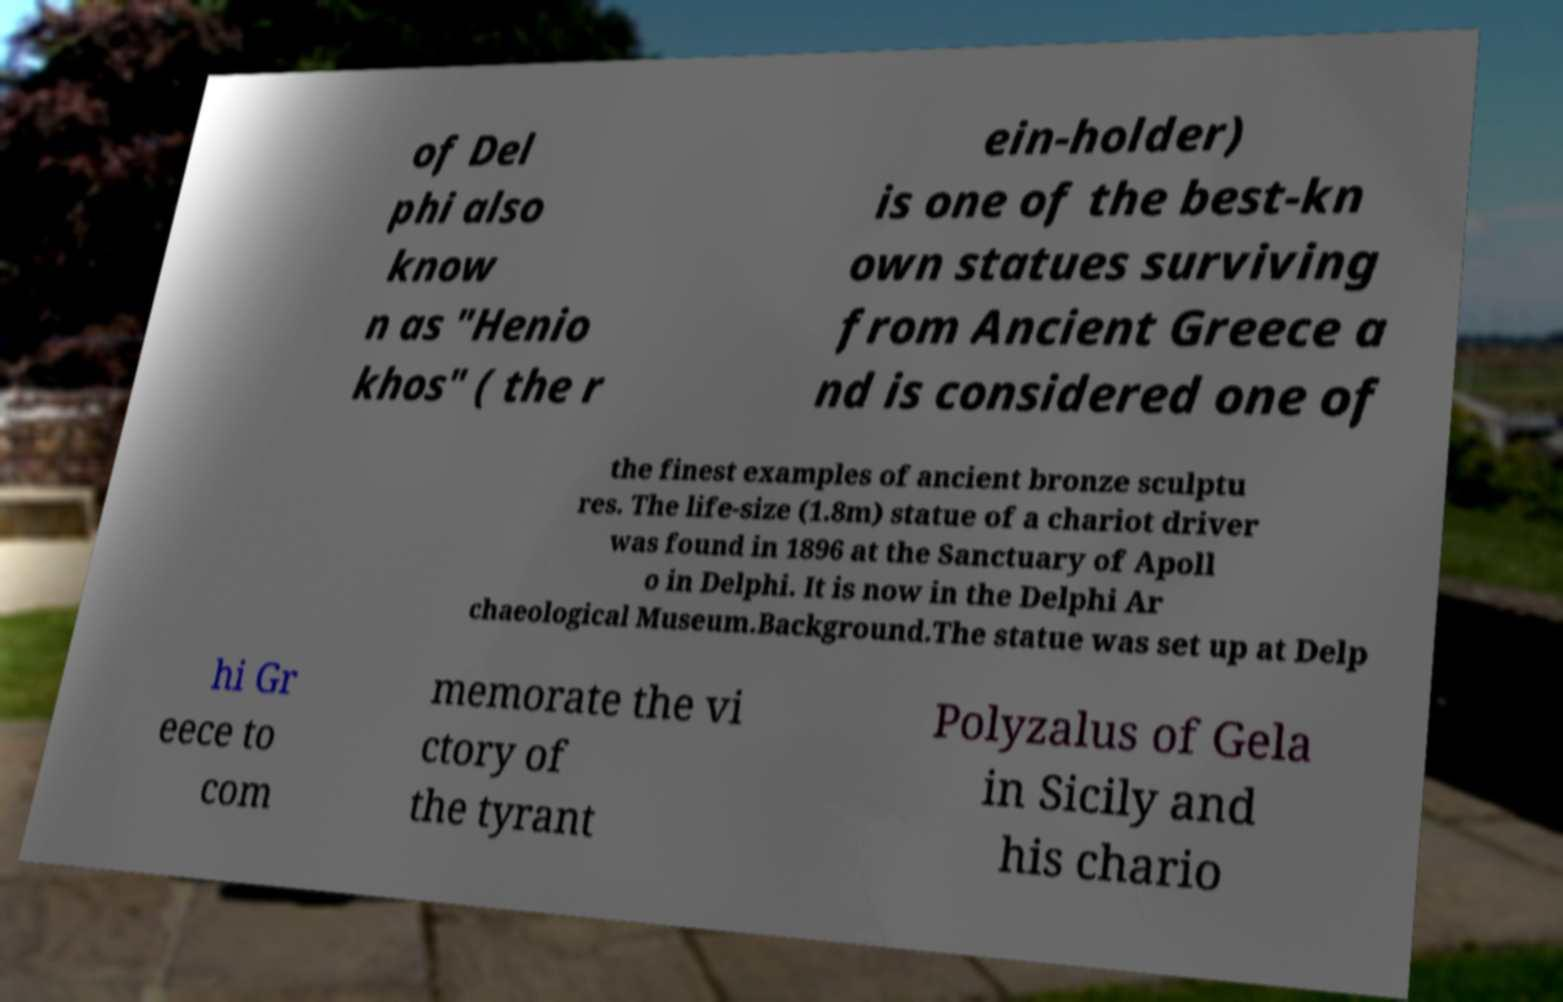Could you assist in decoding the text presented in this image and type it out clearly? of Del phi also know n as "Henio khos" ( the r ein-holder) is one of the best-kn own statues surviving from Ancient Greece a nd is considered one of the finest examples of ancient bronze sculptu res. The life-size (1.8m) statue of a chariot driver was found in 1896 at the Sanctuary of Apoll o in Delphi. It is now in the Delphi Ar chaeological Museum.Background.The statue was set up at Delp hi Gr eece to com memorate the vi ctory of the tyrant Polyzalus of Gela in Sicily and his chario 